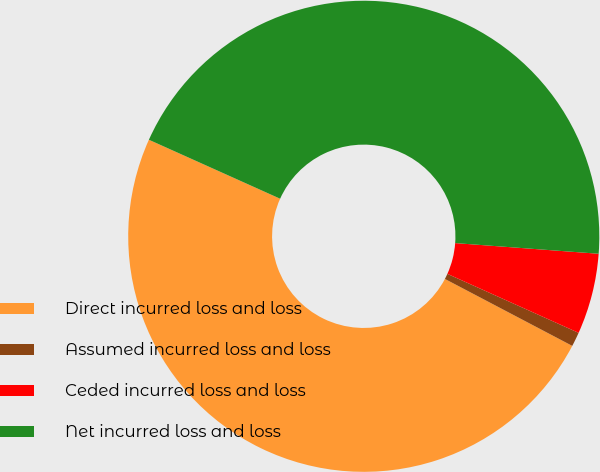Convert chart to OTSL. <chart><loc_0><loc_0><loc_500><loc_500><pie_chart><fcel>Direct incurred loss and loss<fcel>Assumed incurred loss and loss<fcel>Ceded incurred loss and loss<fcel>Net incurred loss and loss<nl><fcel>49.02%<fcel>0.98%<fcel>5.54%<fcel>44.46%<nl></chart> 